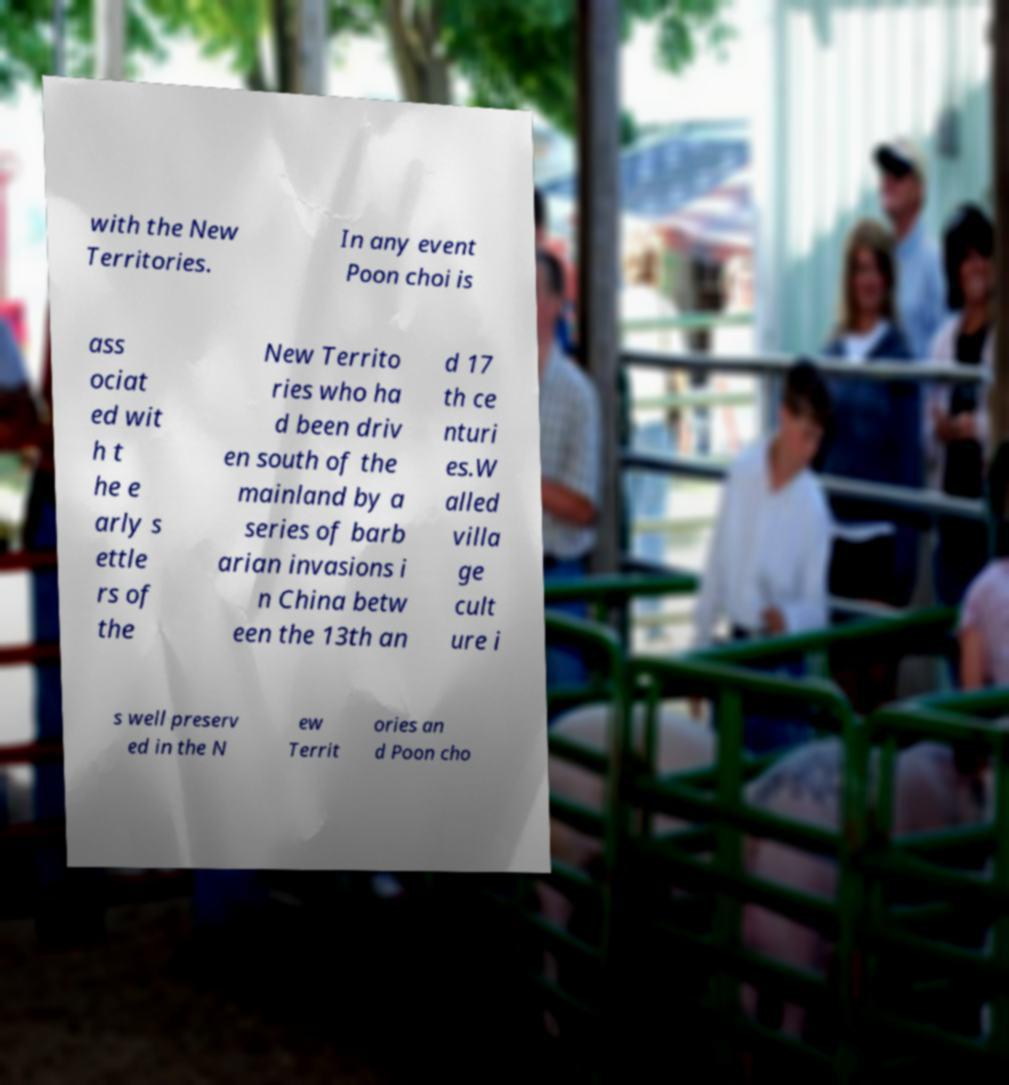There's text embedded in this image that I need extracted. Can you transcribe it verbatim? with the New Territories. In any event Poon choi is ass ociat ed wit h t he e arly s ettle rs of the New Territo ries who ha d been driv en south of the mainland by a series of barb arian invasions i n China betw een the 13th an d 17 th ce nturi es.W alled villa ge cult ure i s well preserv ed in the N ew Territ ories an d Poon cho 